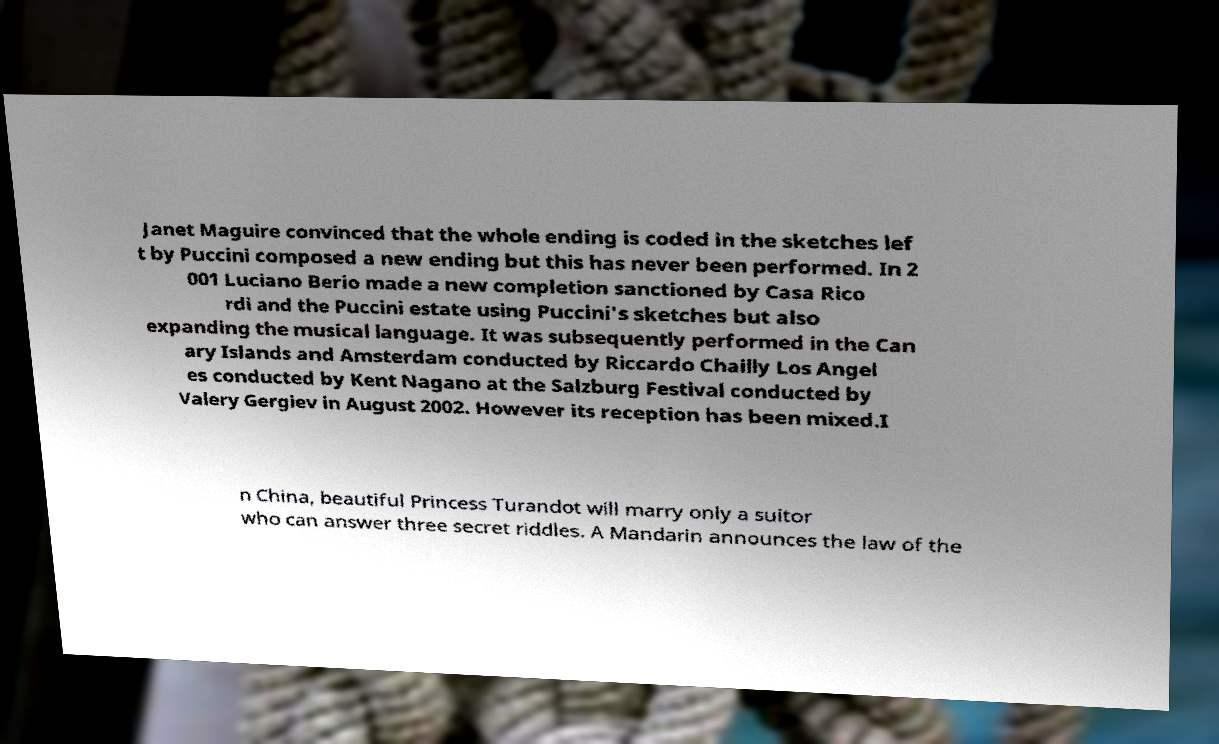For documentation purposes, I need the text within this image transcribed. Could you provide that? Janet Maguire convinced that the whole ending is coded in the sketches lef t by Puccini composed a new ending but this has never been performed. In 2 001 Luciano Berio made a new completion sanctioned by Casa Rico rdi and the Puccini estate using Puccini's sketches but also expanding the musical language. It was subsequently performed in the Can ary Islands and Amsterdam conducted by Riccardo Chailly Los Angel es conducted by Kent Nagano at the Salzburg Festival conducted by Valery Gergiev in August 2002. However its reception has been mixed.I n China, beautiful Princess Turandot will marry only a suitor who can answer three secret riddles. A Mandarin announces the law of the 